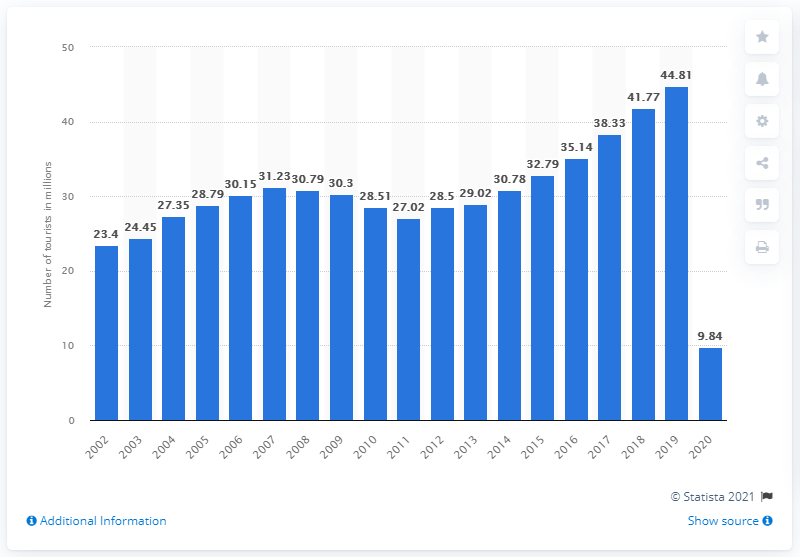Outline some significant characteristics in this image. The number of overseas travelers in the previous year was 44,810. In 2020, approximately 9.84 million U.S. citizens traveled overseas. 